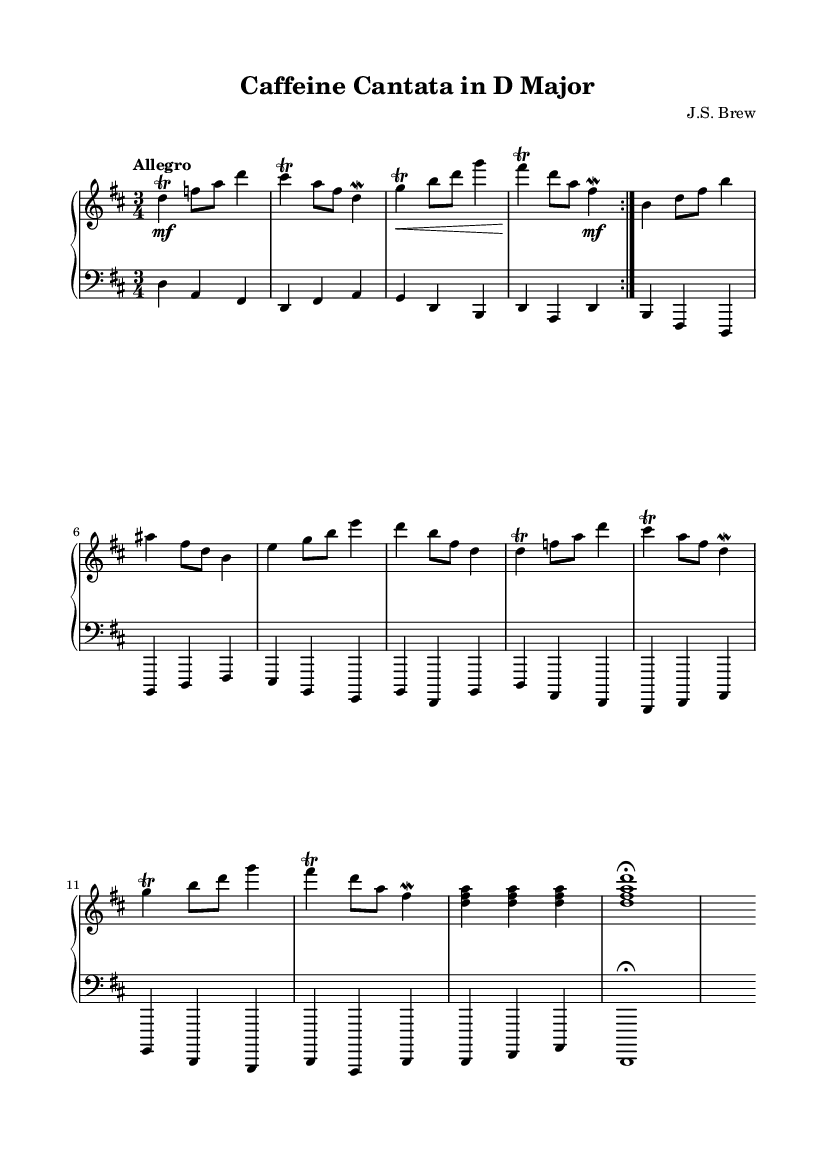What is the key signature of this music? The key signature is indicated at the beginning of the staff. In this case, there are two sharps, which correspond to the notes F# and C#. This identifies the key as D major.
Answer: D major What is the time signature of this piece? The time signature is located at the beginning of the music. The symbol shows there are three beats in each measure, indicated by the "3" on top of the "4." Hence, the time signature is 3/4.
Answer: 3/4 What is the tempo marking for this piece? The tempo indication appears above the staff. It is marked "Allegro," which describes a fast and lively tempo. This helps to define the overall character of the piece.
Answer: Allegro How many measures are in the first section of the piece? By counting the sections in the upper staff, we identify that the first section, repeated as marked, contains 8 measures total (4 measures before and 4 for the repeat).
Answer: 8 measures What type of ornamentation is predominantly used in this score? The score contains frequent trills, as indicated by the "trill" notation above certain notes. This ornamentation is commonly found in Baroque keyboard pieces to embellish melodies.
Answer: Trills What is the final chord at the end of the piece? The final chord is indicated at the end of the lower staff, where a triad consisting of the notes D, F#, and A is shown with an additional D on top. This signifies a D major chord.
Answer: D major chord 